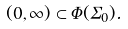Convert formula to latex. <formula><loc_0><loc_0><loc_500><loc_500>( 0 , \infty ) \subset \Phi ( \Sigma _ { 0 } ) .</formula> 